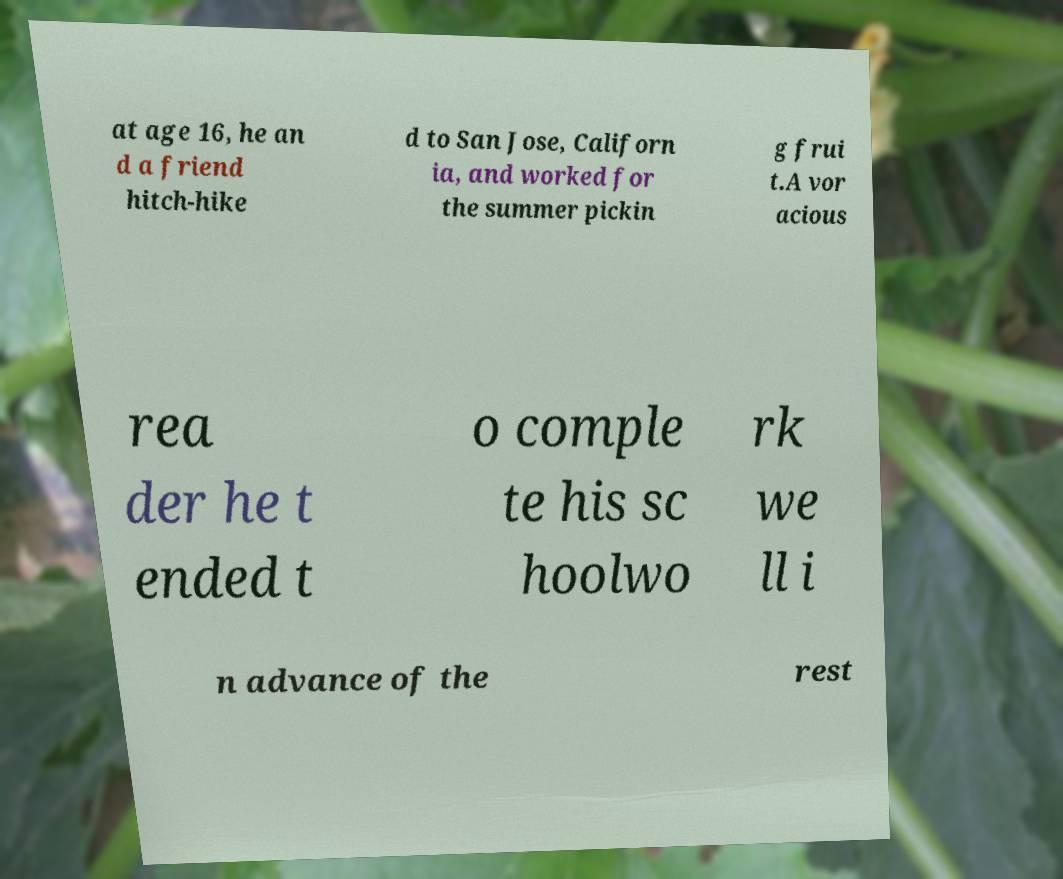I need the written content from this picture converted into text. Can you do that? at age 16, he an d a friend hitch-hike d to San Jose, Californ ia, and worked for the summer pickin g frui t.A vor acious rea der he t ended t o comple te his sc hoolwo rk we ll i n advance of the rest 